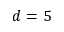<formula> <loc_0><loc_0><loc_500><loc_500>d = 5</formula> 